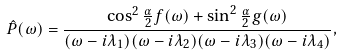<formula> <loc_0><loc_0><loc_500><loc_500>\hat { P } ( \omega ) = \frac { \cos ^ { 2 } \frac { \alpha } { 2 } f ( \omega ) + \sin ^ { 2 } \frac { \alpha } { 2 } g ( \omega ) } { ( \omega - i \lambda _ { 1 } ) ( \omega - i \lambda _ { 2 } ) ( \omega - i \lambda _ { 3 } ) ( \omega - i \lambda _ { 4 } ) } ,</formula> 